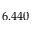<formula> <loc_0><loc_0><loc_500><loc_500>6 . 4 4 0</formula> 